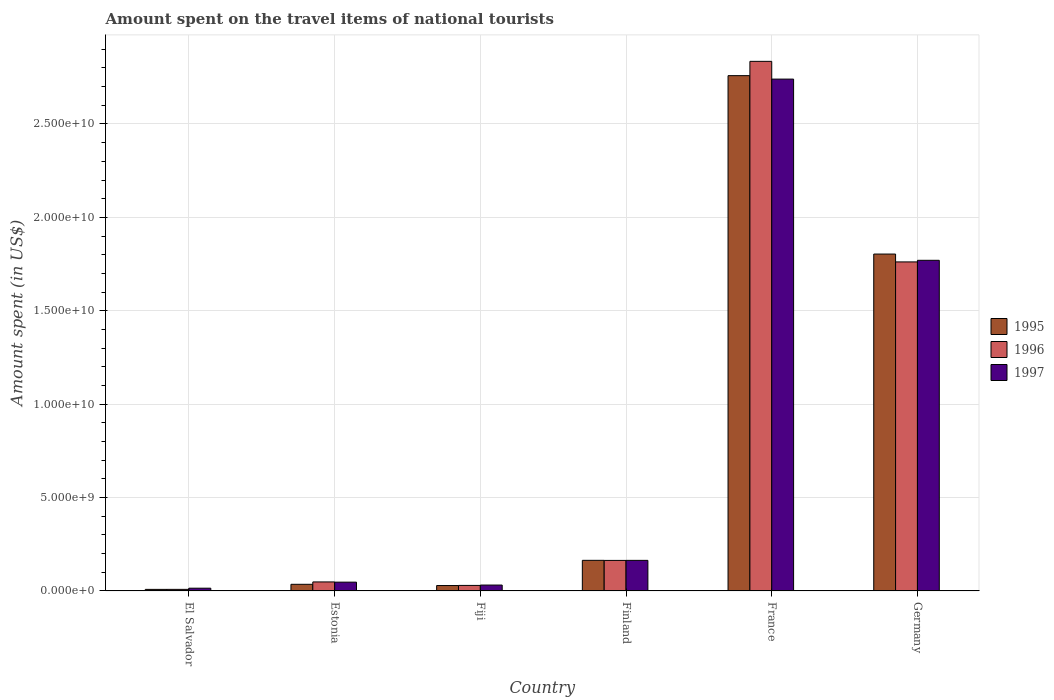How many different coloured bars are there?
Your answer should be very brief. 3. How many groups of bars are there?
Offer a very short reply. 6. Are the number of bars on each tick of the X-axis equal?
Offer a terse response. Yes. How many bars are there on the 4th tick from the left?
Provide a short and direct response. 3. What is the label of the 4th group of bars from the left?
Give a very brief answer. Finland. What is the amount spent on the travel items of national tourists in 1995 in France?
Your response must be concise. 2.76e+1. Across all countries, what is the maximum amount spent on the travel items of national tourists in 1996?
Give a very brief answer. 2.84e+1. Across all countries, what is the minimum amount spent on the travel items of national tourists in 1995?
Offer a very short reply. 8.50e+07. In which country was the amount spent on the travel items of national tourists in 1995 minimum?
Give a very brief answer. El Salvador. What is the total amount spent on the travel items of national tourists in 1995 in the graph?
Give a very brief answer. 4.80e+1. What is the difference between the amount spent on the travel items of national tourists in 1996 in Fiji and that in Finland?
Ensure brevity in your answer.  -1.34e+09. What is the difference between the amount spent on the travel items of national tourists in 1995 in Estonia and the amount spent on the travel items of national tourists in 1996 in Finland?
Your answer should be very brief. -1.28e+09. What is the average amount spent on the travel items of national tourists in 1995 per country?
Keep it short and to the point. 8.00e+09. What is the difference between the amount spent on the travel items of national tourists of/in 1995 and amount spent on the travel items of national tourists of/in 1996 in Fiji?
Offer a very short reply. -7.00e+06. In how many countries, is the amount spent on the travel items of national tourists in 1997 greater than 17000000000 US$?
Your answer should be very brief. 2. What is the ratio of the amount spent on the travel items of national tourists in 1996 in Estonia to that in France?
Your answer should be very brief. 0.02. What is the difference between the highest and the second highest amount spent on the travel items of national tourists in 1997?
Keep it short and to the point. 9.70e+09. What is the difference between the highest and the lowest amount spent on the travel items of national tourists in 1997?
Offer a terse response. 2.73e+1. In how many countries, is the amount spent on the travel items of national tourists in 1996 greater than the average amount spent on the travel items of national tourists in 1996 taken over all countries?
Offer a terse response. 2. What does the 1st bar from the left in Germany represents?
Provide a succinct answer. 1995. What does the 2nd bar from the right in Estonia represents?
Offer a very short reply. 1996. Is it the case that in every country, the sum of the amount spent on the travel items of national tourists in 1995 and amount spent on the travel items of national tourists in 1996 is greater than the amount spent on the travel items of national tourists in 1997?
Make the answer very short. Yes. How many bars are there?
Provide a succinct answer. 18. Are all the bars in the graph horizontal?
Offer a terse response. No. How many countries are there in the graph?
Your answer should be very brief. 6. What is the difference between two consecutive major ticks on the Y-axis?
Make the answer very short. 5.00e+09. Are the values on the major ticks of Y-axis written in scientific E-notation?
Your answer should be compact. Yes. Does the graph contain any zero values?
Keep it short and to the point. No. How many legend labels are there?
Keep it short and to the point. 3. What is the title of the graph?
Make the answer very short. Amount spent on the travel items of national tourists. What is the label or title of the Y-axis?
Offer a terse response. Amount spent (in US$). What is the Amount spent (in US$) in 1995 in El Salvador?
Offer a terse response. 8.50e+07. What is the Amount spent (in US$) of 1996 in El Salvador?
Offer a very short reply. 8.60e+07. What is the Amount spent (in US$) in 1997 in El Salvador?
Your answer should be compact. 1.49e+08. What is the Amount spent (in US$) of 1995 in Estonia?
Provide a short and direct response. 3.57e+08. What is the Amount spent (in US$) in 1996 in Estonia?
Provide a succinct answer. 4.84e+08. What is the Amount spent (in US$) of 1997 in Estonia?
Offer a very short reply. 4.73e+08. What is the Amount spent (in US$) in 1995 in Fiji?
Give a very brief answer. 2.91e+08. What is the Amount spent (in US$) in 1996 in Fiji?
Your response must be concise. 2.98e+08. What is the Amount spent (in US$) in 1997 in Fiji?
Offer a terse response. 3.17e+08. What is the Amount spent (in US$) of 1995 in Finland?
Your answer should be compact. 1.64e+09. What is the Amount spent (in US$) in 1996 in Finland?
Keep it short and to the point. 1.64e+09. What is the Amount spent (in US$) of 1997 in Finland?
Offer a terse response. 1.64e+09. What is the Amount spent (in US$) in 1995 in France?
Ensure brevity in your answer.  2.76e+1. What is the Amount spent (in US$) of 1996 in France?
Provide a short and direct response. 2.84e+1. What is the Amount spent (in US$) of 1997 in France?
Offer a terse response. 2.74e+1. What is the Amount spent (in US$) in 1995 in Germany?
Provide a short and direct response. 1.80e+1. What is the Amount spent (in US$) in 1996 in Germany?
Provide a short and direct response. 1.76e+1. What is the Amount spent (in US$) in 1997 in Germany?
Your response must be concise. 1.77e+1. Across all countries, what is the maximum Amount spent (in US$) of 1995?
Make the answer very short. 2.76e+1. Across all countries, what is the maximum Amount spent (in US$) in 1996?
Offer a very short reply. 2.84e+1. Across all countries, what is the maximum Amount spent (in US$) of 1997?
Your response must be concise. 2.74e+1. Across all countries, what is the minimum Amount spent (in US$) in 1995?
Offer a very short reply. 8.50e+07. Across all countries, what is the minimum Amount spent (in US$) in 1996?
Keep it short and to the point. 8.60e+07. Across all countries, what is the minimum Amount spent (in US$) in 1997?
Offer a terse response. 1.49e+08. What is the total Amount spent (in US$) in 1995 in the graph?
Your response must be concise. 4.80e+1. What is the total Amount spent (in US$) of 1996 in the graph?
Ensure brevity in your answer.  4.85e+1. What is the total Amount spent (in US$) in 1997 in the graph?
Your answer should be compact. 4.77e+1. What is the difference between the Amount spent (in US$) in 1995 in El Salvador and that in Estonia?
Your answer should be compact. -2.72e+08. What is the difference between the Amount spent (in US$) of 1996 in El Salvador and that in Estonia?
Ensure brevity in your answer.  -3.98e+08. What is the difference between the Amount spent (in US$) in 1997 in El Salvador and that in Estonia?
Offer a terse response. -3.24e+08. What is the difference between the Amount spent (in US$) of 1995 in El Salvador and that in Fiji?
Give a very brief answer. -2.06e+08. What is the difference between the Amount spent (in US$) of 1996 in El Salvador and that in Fiji?
Your answer should be compact. -2.12e+08. What is the difference between the Amount spent (in US$) in 1997 in El Salvador and that in Fiji?
Make the answer very short. -1.68e+08. What is the difference between the Amount spent (in US$) of 1995 in El Salvador and that in Finland?
Offer a very short reply. -1.56e+09. What is the difference between the Amount spent (in US$) of 1996 in El Salvador and that in Finland?
Make the answer very short. -1.55e+09. What is the difference between the Amount spent (in US$) in 1997 in El Salvador and that in Finland?
Keep it short and to the point. -1.49e+09. What is the difference between the Amount spent (in US$) in 1995 in El Salvador and that in France?
Offer a very short reply. -2.75e+1. What is the difference between the Amount spent (in US$) of 1996 in El Salvador and that in France?
Provide a succinct answer. -2.83e+1. What is the difference between the Amount spent (in US$) in 1997 in El Salvador and that in France?
Ensure brevity in your answer.  -2.73e+1. What is the difference between the Amount spent (in US$) of 1995 in El Salvador and that in Germany?
Ensure brevity in your answer.  -1.80e+1. What is the difference between the Amount spent (in US$) of 1996 in El Salvador and that in Germany?
Offer a terse response. -1.75e+1. What is the difference between the Amount spent (in US$) of 1997 in El Salvador and that in Germany?
Provide a succinct answer. -1.76e+1. What is the difference between the Amount spent (in US$) in 1995 in Estonia and that in Fiji?
Your answer should be very brief. 6.60e+07. What is the difference between the Amount spent (in US$) of 1996 in Estonia and that in Fiji?
Your answer should be compact. 1.86e+08. What is the difference between the Amount spent (in US$) of 1997 in Estonia and that in Fiji?
Give a very brief answer. 1.56e+08. What is the difference between the Amount spent (in US$) of 1995 in Estonia and that in Finland?
Give a very brief answer. -1.28e+09. What is the difference between the Amount spent (in US$) in 1996 in Estonia and that in Finland?
Provide a succinct answer. -1.15e+09. What is the difference between the Amount spent (in US$) of 1997 in Estonia and that in Finland?
Offer a very short reply. -1.17e+09. What is the difference between the Amount spent (in US$) in 1995 in Estonia and that in France?
Your answer should be compact. -2.72e+1. What is the difference between the Amount spent (in US$) in 1996 in Estonia and that in France?
Offer a very short reply. -2.79e+1. What is the difference between the Amount spent (in US$) in 1997 in Estonia and that in France?
Keep it short and to the point. -2.69e+1. What is the difference between the Amount spent (in US$) of 1995 in Estonia and that in Germany?
Give a very brief answer. -1.77e+1. What is the difference between the Amount spent (in US$) in 1996 in Estonia and that in Germany?
Give a very brief answer. -1.71e+1. What is the difference between the Amount spent (in US$) of 1997 in Estonia and that in Germany?
Provide a short and direct response. -1.72e+1. What is the difference between the Amount spent (in US$) of 1995 in Fiji and that in Finland?
Your answer should be compact. -1.35e+09. What is the difference between the Amount spent (in US$) of 1996 in Fiji and that in Finland?
Your answer should be compact. -1.34e+09. What is the difference between the Amount spent (in US$) of 1997 in Fiji and that in Finland?
Provide a short and direct response. -1.32e+09. What is the difference between the Amount spent (in US$) in 1995 in Fiji and that in France?
Your response must be concise. -2.73e+1. What is the difference between the Amount spent (in US$) in 1996 in Fiji and that in France?
Give a very brief answer. -2.81e+1. What is the difference between the Amount spent (in US$) in 1997 in Fiji and that in France?
Make the answer very short. -2.71e+1. What is the difference between the Amount spent (in US$) of 1995 in Fiji and that in Germany?
Your answer should be compact. -1.77e+1. What is the difference between the Amount spent (in US$) in 1996 in Fiji and that in Germany?
Offer a terse response. -1.73e+1. What is the difference between the Amount spent (in US$) in 1997 in Fiji and that in Germany?
Offer a terse response. -1.74e+1. What is the difference between the Amount spent (in US$) in 1995 in Finland and that in France?
Your response must be concise. -2.59e+1. What is the difference between the Amount spent (in US$) of 1996 in Finland and that in France?
Your answer should be very brief. -2.67e+1. What is the difference between the Amount spent (in US$) in 1997 in Finland and that in France?
Offer a very short reply. -2.58e+1. What is the difference between the Amount spent (in US$) in 1995 in Finland and that in Germany?
Offer a terse response. -1.64e+1. What is the difference between the Amount spent (in US$) of 1996 in Finland and that in Germany?
Keep it short and to the point. -1.60e+1. What is the difference between the Amount spent (in US$) in 1997 in Finland and that in Germany?
Provide a succinct answer. -1.61e+1. What is the difference between the Amount spent (in US$) of 1995 in France and that in Germany?
Ensure brevity in your answer.  9.55e+09. What is the difference between the Amount spent (in US$) in 1996 in France and that in Germany?
Provide a succinct answer. 1.07e+1. What is the difference between the Amount spent (in US$) in 1997 in France and that in Germany?
Provide a short and direct response. 9.70e+09. What is the difference between the Amount spent (in US$) of 1995 in El Salvador and the Amount spent (in US$) of 1996 in Estonia?
Offer a terse response. -3.99e+08. What is the difference between the Amount spent (in US$) of 1995 in El Salvador and the Amount spent (in US$) of 1997 in Estonia?
Provide a succinct answer. -3.88e+08. What is the difference between the Amount spent (in US$) of 1996 in El Salvador and the Amount spent (in US$) of 1997 in Estonia?
Provide a short and direct response. -3.87e+08. What is the difference between the Amount spent (in US$) in 1995 in El Salvador and the Amount spent (in US$) in 1996 in Fiji?
Keep it short and to the point. -2.13e+08. What is the difference between the Amount spent (in US$) in 1995 in El Salvador and the Amount spent (in US$) in 1997 in Fiji?
Provide a succinct answer. -2.32e+08. What is the difference between the Amount spent (in US$) in 1996 in El Salvador and the Amount spent (in US$) in 1997 in Fiji?
Ensure brevity in your answer.  -2.31e+08. What is the difference between the Amount spent (in US$) in 1995 in El Salvador and the Amount spent (in US$) in 1996 in Finland?
Offer a terse response. -1.55e+09. What is the difference between the Amount spent (in US$) in 1995 in El Salvador and the Amount spent (in US$) in 1997 in Finland?
Provide a short and direct response. -1.55e+09. What is the difference between the Amount spent (in US$) of 1996 in El Salvador and the Amount spent (in US$) of 1997 in Finland?
Provide a short and direct response. -1.55e+09. What is the difference between the Amount spent (in US$) of 1995 in El Salvador and the Amount spent (in US$) of 1996 in France?
Your response must be concise. -2.83e+1. What is the difference between the Amount spent (in US$) of 1995 in El Salvador and the Amount spent (in US$) of 1997 in France?
Your answer should be compact. -2.73e+1. What is the difference between the Amount spent (in US$) in 1996 in El Salvador and the Amount spent (in US$) in 1997 in France?
Your response must be concise. -2.73e+1. What is the difference between the Amount spent (in US$) of 1995 in El Salvador and the Amount spent (in US$) of 1996 in Germany?
Ensure brevity in your answer.  -1.75e+1. What is the difference between the Amount spent (in US$) in 1995 in El Salvador and the Amount spent (in US$) in 1997 in Germany?
Offer a terse response. -1.76e+1. What is the difference between the Amount spent (in US$) in 1996 in El Salvador and the Amount spent (in US$) in 1997 in Germany?
Your answer should be compact. -1.76e+1. What is the difference between the Amount spent (in US$) of 1995 in Estonia and the Amount spent (in US$) of 1996 in Fiji?
Make the answer very short. 5.90e+07. What is the difference between the Amount spent (in US$) in 1995 in Estonia and the Amount spent (in US$) in 1997 in Fiji?
Provide a short and direct response. 4.00e+07. What is the difference between the Amount spent (in US$) in 1996 in Estonia and the Amount spent (in US$) in 1997 in Fiji?
Your response must be concise. 1.67e+08. What is the difference between the Amount spent (in US$) in 1995 in Estonia and the Amount spent (in US$) in 1996 in Finland?
Your answer should be compact. -1.28e+09. What is the difference between the Amount spent (in US$) in 1995 in Estonia and the Amount spent (in US$) in 1997 in Finland?
Provide a succinct answer. -1.28e+09. What is the difference between the Amount spent (in US$) in 1996 in Estonia and the Amount spent (in US$) in 1997 in Finland?
Offer a very short reply. -1.16e+09. What is the difference between the Amount spent (in US$) in 1995 in Estonia and the Amount spent (in US$) in 1996 in France?
Ensure brevity in your answer.  -2.80e+1. What is the difference between the Amount spent (in US$) of 1995 in Estonia and the Amount spent (in US$) of 1997 in France?
Ensure brevity in your answer.  -2.70e+1. What is the difference between the Amount spent (in US$) in 1996 in Estonia and the Amount spent (in US$) in 1997 in France?
Provide a short and direct response. -2.69e+1. What is the difference between the Amount spent (in US$) of 1995 in Estonia and the Amount spent (in US$) of 1996 in Germany?
Offer a very short reply. -1.73e+1. What is the difference between the Amount spent (in US$) in 1995 in Estonia and the Amount spent (in US$) in 1997 in Germany?
Provide a succinct answer. -1.73e+1. What is the difference between the Amount spent (in US$) in 1996 in Estonia and the Amount spent (in US$) in 1997 in Germany?
Keep it short and to the point. -1.72e+1. What is the difference between the Amount spent (in US$) in 1995 in Fiji and the Amount spent (in US$) in 1996 in Finland?
Your answer should be very brief. -1.34e+09. What is the difference between the Amount spent (in US$) of 1995 in Fiji and the Amount spent (in US$) of 1997 in Finland?
Your answer should be very brief. -1.35e+09. What is the difference between the Amount spent (in US$) of 1996 in Fiji and the Amount spent (in US$) of 1997 in Finland?
Your answer should be very brief. -1.34e+09. What is the difference between the Amount spent (in US$) of 1995 in Fiji and the Amount spent (in US$) of 1996 in France?
Give a very brief answer. -2.81e+1. What is the difference between the Amount spent (in US$) in 1995 in Fiji and the Amount spent (in US$) in 1997 in France?
Ensure brevity in your answer.  -2.71e+1. What is the difference between the Amount spent (in US$) of 1996 in Fiji and the Amount spent (in US$) of 1997 in France?
Ensure brevity in your answer.  -2.71e+1. What is the difference between the Amount spent (in US$) of 1995 in Fiji and the Amount spent (in US$) of 1996 in Germany?
Your answer should be compact. -1.73e+1. What is the difference between the Amount spent (in US$) in 1995 in Fiji and the Amount spent (in US$) in 1997 in Germany?
Ensure brevity in your answer.  -1.74e+1. What is the difference between the Amount spent (in US$) in 1996 in Fiji and the Amount spent (in US$) in 1997 in Germany?
Your answer should be compact. -1.74e+1. What is the difference between the Amount spent (in US$) of 1995 in Finland and the Amount spent (in US$) of 1996 in France?
Provide a succinct answer. -2.67e+1. What is the difference between the Amount spent (in US$) of 1995 in Finland and the Amount spent (in US$) of 1997 in France?
Make the answer very short. -2.58e+1. What is the difference between the Amount spent (in US$) of 1996 in Finland and the Amount spent (in US$) of 1997 in France?
Offer a terse response. -2.58e+1. What is the difference between the Amount spent (in US$) of 1995 in Finland and the Amount spent (in US$) of 1996 in Germany?
Offer a terse response. -1.60e+1. What is the difference between the Amount spent (in US$) of 1995 in Finland and the Amount spent (in US$) of 1997 in Germany?
Your response must be concise. -1.61e+1. What is the difference between the Amount spent (in US$) of 1996 in Finland and the Amount spent (in US$) of 1997 in Germany?
Offer a terse response. -1.61e+1. What is the difference between the Amount spent (in US$) in 1995 in France and the Amount spent (in US$) in 1996 in Germany?
Ensure brevity in your answer.  9.97e+09. What is the difference between the Amount spent (in US$) in 1995 in France and the Amount spent (in US$) in 1997 in Germany?
Offer a very short reply. 9.88e+09. What is the difference between the Amount spent (in US$) in 1996 in France and the Amount spent (in US$) in 1997 in Germany?
Provide a short and direct response. 1.06e+1. What is the average Amount spent (in US$) in 1995 per country?
Give a very brief answer. 8.00e+09. What is the average Amount spent (in US$) of 1996 per country?
Your response must be concise. 8.08e+09. What is the average Amount spent (in US$) in 1997 per country?
Your answer should be very brief. 7.95e+09. What is the difference between the Amount spent (in US$) of 1995 and Amount spent (in US$) of 1997 in El Salvador?
Make the answer very short. -6.40e+07. What is the difference between the Amount spent (in US$) of 1996 and Amount spent (in US$) of 1997 in El Salvador?
Your answer should be very brief. -6.30e+07. What is the difference between the Amount spent (in US$) in 1995 and Amount spent (in US$) in 1996 in Estonia?
Provide a short and direct response. -1.27e+08. What is the difference between the Amount spent (in US$) in 1995 and Amount spent (in US$) in 1997 in Estonia?
Provide a succinct answer. -1.16e+08. What is the difference between the Amount spent (in US$) of 1996 and Amount spent (in US$) of 1997 in Estonia?
Your response must be concise. 1.10e+07. What is the difference between the Amount spent (in US$) of 1995 and Amount spent (in US$) of 1996 in Fiji?
Keep it short and to the point. -7.00e+06. What is the difference between the Amount spent (in US$) of 1995 and Amount spent (in US$) of 1997 in Fiji?
Provide a short and direct response. -2.60e+07. What is the difference between the Amount spent (in US$) in 1996 and Amount spent (in US$) in 1997 in Fiji?
Your answer should be very brief. -1.90e+07. What is the difference between the Amount spent (in US$) of 1995 and Amount spent (in US$) of 1996 in Finland?
Provide a succinct answer. 4.00e+06. What is the difference between the Amount spent (in US$) in 1996 and Amount spent (in US$) in 1997 in Finland?
Provide a short and direct response. -3.00e+06. What is the difference between the Amount spent (in US$) in 1995 and Amount spent (in US$) in 1996 in France?
Make the answer very short. -7.65e+08. What is the difference between the Amount spent (in US$) of 1995 and Amount spent (in US$) of 1997 in France?
Your response must be concise. 1.85e+08. What is the difference between the Amount spent (in US$) in 1996 and Amount spent (in US$) in 1997 in France?
Provide a short and direct response. 9.50e+08. What is the difference between the Amount spent (in US$) of 1995 and Amount spent (in US$) of 1996 in Germany?
Make the answer very short. 4.20e+08. What is the difference between the Amount spent (in US$) of 1995 and Amount spent (in US$) of 1997 in Germany?
Your answer should be compact. 3.34e+08. What is the difference between the Amount spent (in US$) in 1996 and Amount spent (in US$) in 1997 in Germany?
Offer a terse response. -8.60e+07. What is the ratio of the Amount spent (in US$) in 1995 in El Salvador to that in Estonia?
Make the answer very short. 0.24. What is the ratio of the Amount spent (in US$) of 1996 in El Salvador to that in Estonia?
Provide a short and direct response. 0.18. What is the ratio of the Amount spent (in US$) of 1997 in El Salvador to that in Estonia?
Give a very brief answer. 0.32. What is the ratio of the Amount spent (in US$) in 1995 in El Salvador to that in Fiji?
Give a very brief answer. 0.29. What is the ratio of the Amount spent (in US$) in 1996 in El Salvador to that in Fiji?
Keep it short and to the point. 0.29. What is the ratio of the Amount spent (in US$) of 1997 in El Salvador to that in Fiji?
Make the answer very short. 0.47. What is the ratio of the Amount spent (in US$) in 1995 in El Salvador to that in Finland?
Keep it short and to the point. 0.05. What is the ratio of the Amount spent (in US$) in 1996 in El Salvador to that in Finland?
Your response must be concise. 0.05. What is the ratio of the Amount spent (in US$) in 1997 in El Salvador to that in Finland?
Give a very brief answer. 0.09. What is the ratio of the Amount spent (in US$) of 1995 in El Salvador to that in France?
Offer a very short reply. 0. What is the ratio of the Amount spent (in US$) of 1996 in El Salvador to that in France?
Your answer should be very brief. 0. What is the ratio of the Amount spent (in US$) in 1997 in El Salvador to that in France?
Ensure brevity in your answer.  0.01. What is the ratio of the Amount spent (in US$) in 1995 in El Salvador to that in Germany?
Your response must be concise. 0. What is the ratio of the Amount spent (in US$) of 1996 in El Salvador to that in Germany?
Your response must be concise. 0. What is the ratio of the Amount spent (in US$) of 1997 in El Salvador to that in Germany?
Your response must be concise. 0.01. What is the ratio of the Amount spent (in US$) in 1995 in Estonia to that in Fiji?
Give a very brief answer. 1.23. What is the ratio of the Amount spent (in US$) in 1996 in Estonia to that in Fiji?
Give a very brief answer. 1.62. What is the ratio of the Amount spent (in US$) in 1997 in Estonia to that in Fiji?
Offer a very short reply. 1.49. What is the ratio of the Amount spent (in US$) in 1995 in Estonia to that in Finland?
Your answer should be very brief. 0.22. What is the ratio of the Amount spent (in US$) of 1996 in Estonia to that in Finland?
Provide a succinct answer. 0.3. What is the ratio of the Amount spent (in US$) of 1997 in Estonia to that in Finland?
Make the answer very short. 0.29. What is the ratio of the Amount spent (in US$) in 1995 in Estonia to that in France?
Ensure brevity in your answer.  0.01. What is the ratio of the Amount spent (in US$) of 1996 in Estonia to that in France?
Offer a very short reply. 0.02. What is the ratio of the Amount spent (in US$) of 1997 in Estonia to that in France?
Ensure brevity in your answer.  0.02. What is the ratio of the Amount spent (in US$) in 1995 in Estonia to that in Germany?
Ensure brevity in your answer.  0.02. What is the ratio of the Amount spent (in US$) in 1996 in Estonia to that in Germany?
Make the answer very short. 0.03. What is the ratio of the Amount spent (in US$) in 1997 in Estonia to that in Germany?
Give a very brief answer. 0.03. What is the ratio of the Amount spent (in US$) in 1995 in Fiji to that in Finland?
Offer a very short reply. 0.18. What is the ratio of the Amount spent (in US$) of 1996 in Fiji to that in Finland?
Provide a short and direct response. 0.18. What is the ratio of the Amount spent (in US$) in 1997 in Fiji to that in Finland?
Make the answer very short. 0.19. What is the ratio of the Amount spent (in US$) of 1995 in Fiji to that in France?
Ensure brevity in your answer.  0.01. What is the ratio of the Amount spent (in US$) in 1996 in Fiji to that in France?
Your answer should be very brief. 0.01. What is the ratio of the Amount spent (in US$) of 1997 in Fiji to that in France?
Offer a very short reply. 0.01. What is the ratio of the Amount spent (in US$) in 1995 in Fiji to that in Germany?
Your answer should be compact. 0.02. What is the ratio of the Amount spent (in US$) in 1996 in Fiji to that in Germany?
Your answer should be very brief. 0.02. What is the ratio of the Amount spent (in US$) of 1997 in Fiji to that in Germany?
Offer a terse response. 0.02. What is the ratio of the Amount spent (in US$) in 1995 in Finland to that in France?
Ensure brevity in your answer.  0.06. What is the ratio of the Amount spent (in US$) in 1996 in Finland to that in France?
Your answer should be very brief. 0.06. What is the ratio of the Amount spent (in US$) of 1997 in Finland to that in France?
Give a very brief answer. 0.06. What is the ratio of the Amount spent (in US$) of 1995 in Finland to that in Germany?
Your answer should be compact. 0.09. What is the ratio of the Amount spent (in US$) of 1996 in Finland to that in Germany?
Give a very brief answer. 0.09. What is the ratio of the Amount spent (in US$) in 1997 in Finland to that in Germany?
Provide a succinct answer. 0.09. What is the ratio of the Amount spent (in US$) in 1995 in France to that in Germany?
Make the answer very short. 1.53. What is the ratio of the Amount spent (in US$) of 1996 in France to that in Germany?
Offer a terse response. 1.61. What is the ratio of the Amount spent (in US$) of 1997 in France to that in Germany?
Offer a terse response. 1.55. What is the difference between the highest and the second highest Amount spent (in US$) in 1995?
Keep it short and to the point. 9.55e+09. What is the difference between the highest and the second highest Amount spent (in US$) of 1996?
Ensure brevity in your answer.  1.07e+1. What is the difference between the highest and the second highest Amount spent (in US$) of 1997?
Keep it short and to the point. 9.70e+09. What is the difference between the highest and the lowest Amount spent (in US$) in 1995?
Offer a terse response. 2.75e+1. What is the difference between the highest and the lowest Amount spent (in US$) of 1996?
Offer a very short reply. 2.83e+1. What is the difference between the highest and the lowest Amount spent (in US$) in 1997?
Your answer should be compact. 2.73e+1. 